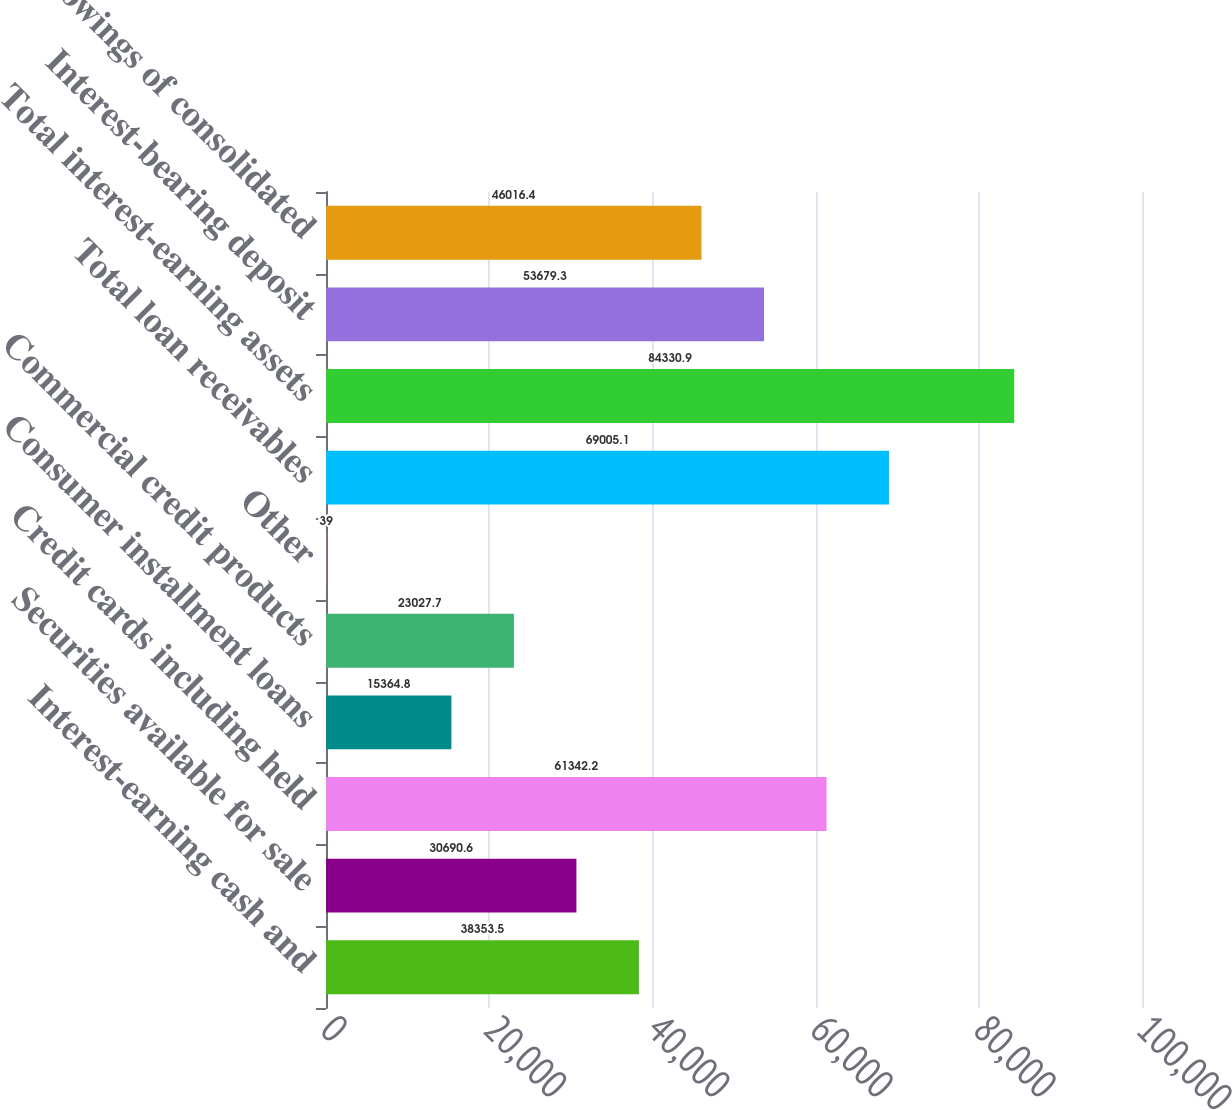Convert chart to OTSL. <chart><loc_0><loc_0><loc_500><loc_500><bar_chart><fcel>Interest-earning cash and<fcel>Securities available for sale<fcel>Credit cards including held<fcel>Consumer installment loans<fcel>Commercial credit products<fcel>Other<fcel>Total loan receivables<fcel>Total interest-earning assets<fcel>Interest-bearing deposit<fcel>Borrowings of consolidated<nl><fcel>38353.5<fcel>30690.6<fcel>61342.2<fcel>15364.8<fcel>23027.7<fcel>39<fcel>69005.1<fcel>84330.9<fcel>53679.3<fcel>46016.4<nl></chart> 